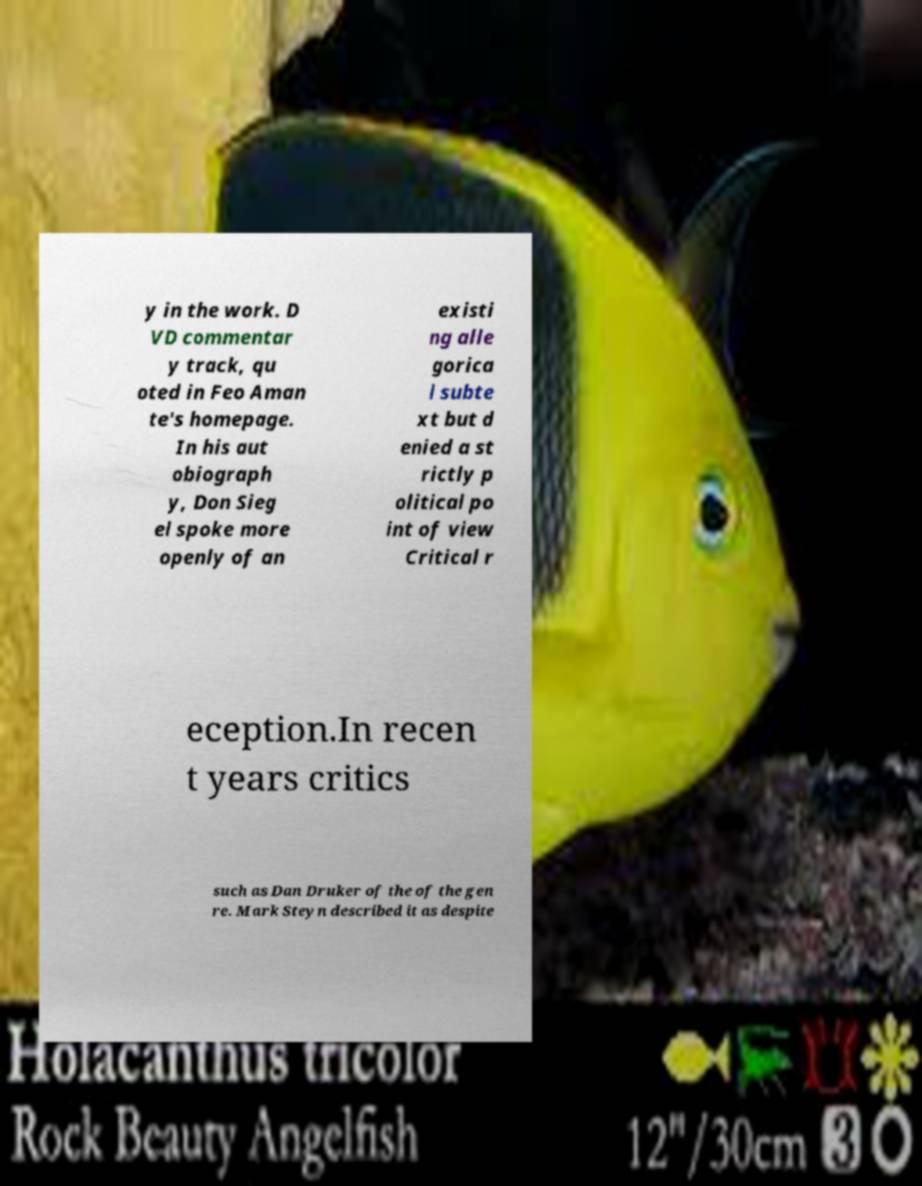Can you accurately transcribe the text from the provided image for me? y in the work. D VD commentar y track, qu oted in Feo Aman te's homepage. In his aut obiograph y, Don Sieg el spoke more openly of an existi ng alle gorica l subte xt but d enied a st rictly p olitical po int of view Critical r eception.In recen t years critics such as Dan Druker of the of the gen re. Mark Steyn described it as despite 